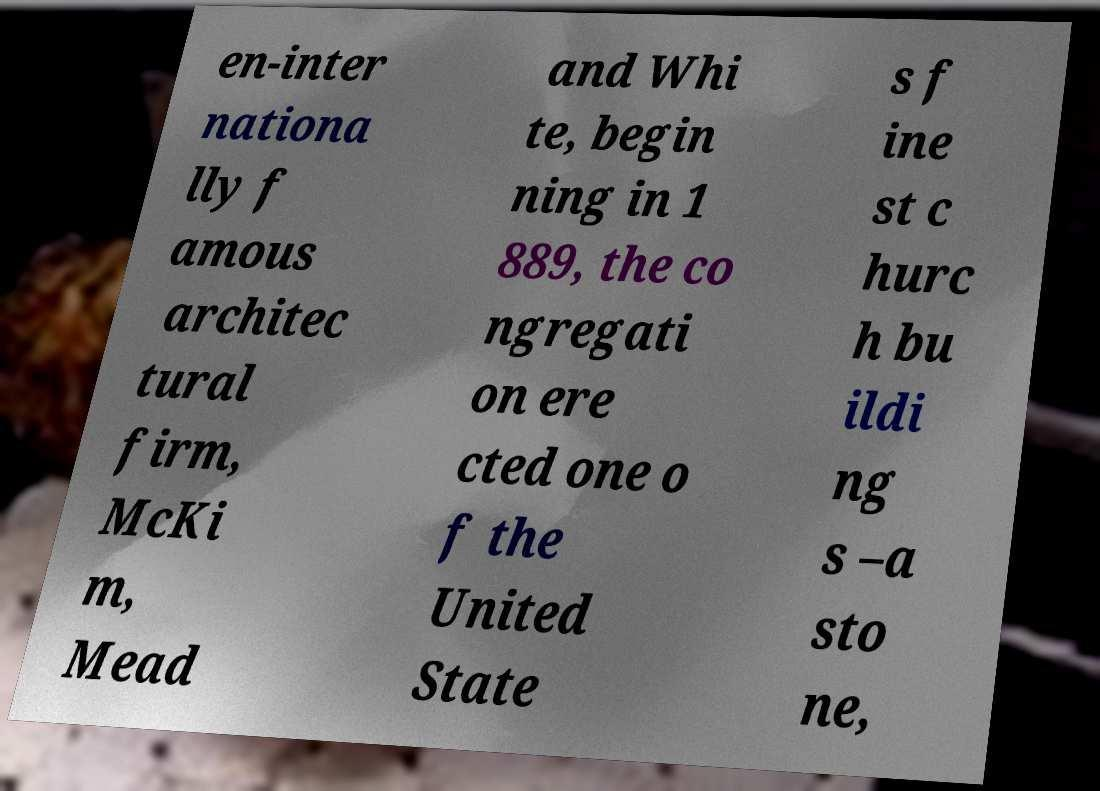Please read and relay the text visible in this image. What does it say? en-inter nationa lly f amous architec tural firm, McKi m, Mead and Whi te, begin ning in 1 889, the co ngregati on ere cted one o f the United State s f ine st c hurc h bu ildi ng s –a sto ne, 